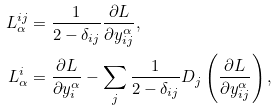<formula> <loc_0><loc_0><loc_500><loc_500>L _ { \alpha } ^ { i j } & = \frac { 1 } { 2 - \delta _ { i j } } \frac { \partial L } { \partial y _ { i j } ^ { \alpha } } , \\ L _ { \alpha } ^ { i } & = \frac { \partial L } { \partial y _ { i } ^ { \alpha } } - \sum _ { j } \frac { 1 } { 2 - \delta _ { i j } } D _ { j } \left ( \frac { \partial L } { \partial y _ { i j } ^ { \alpha } } \right ) ,</formula> 